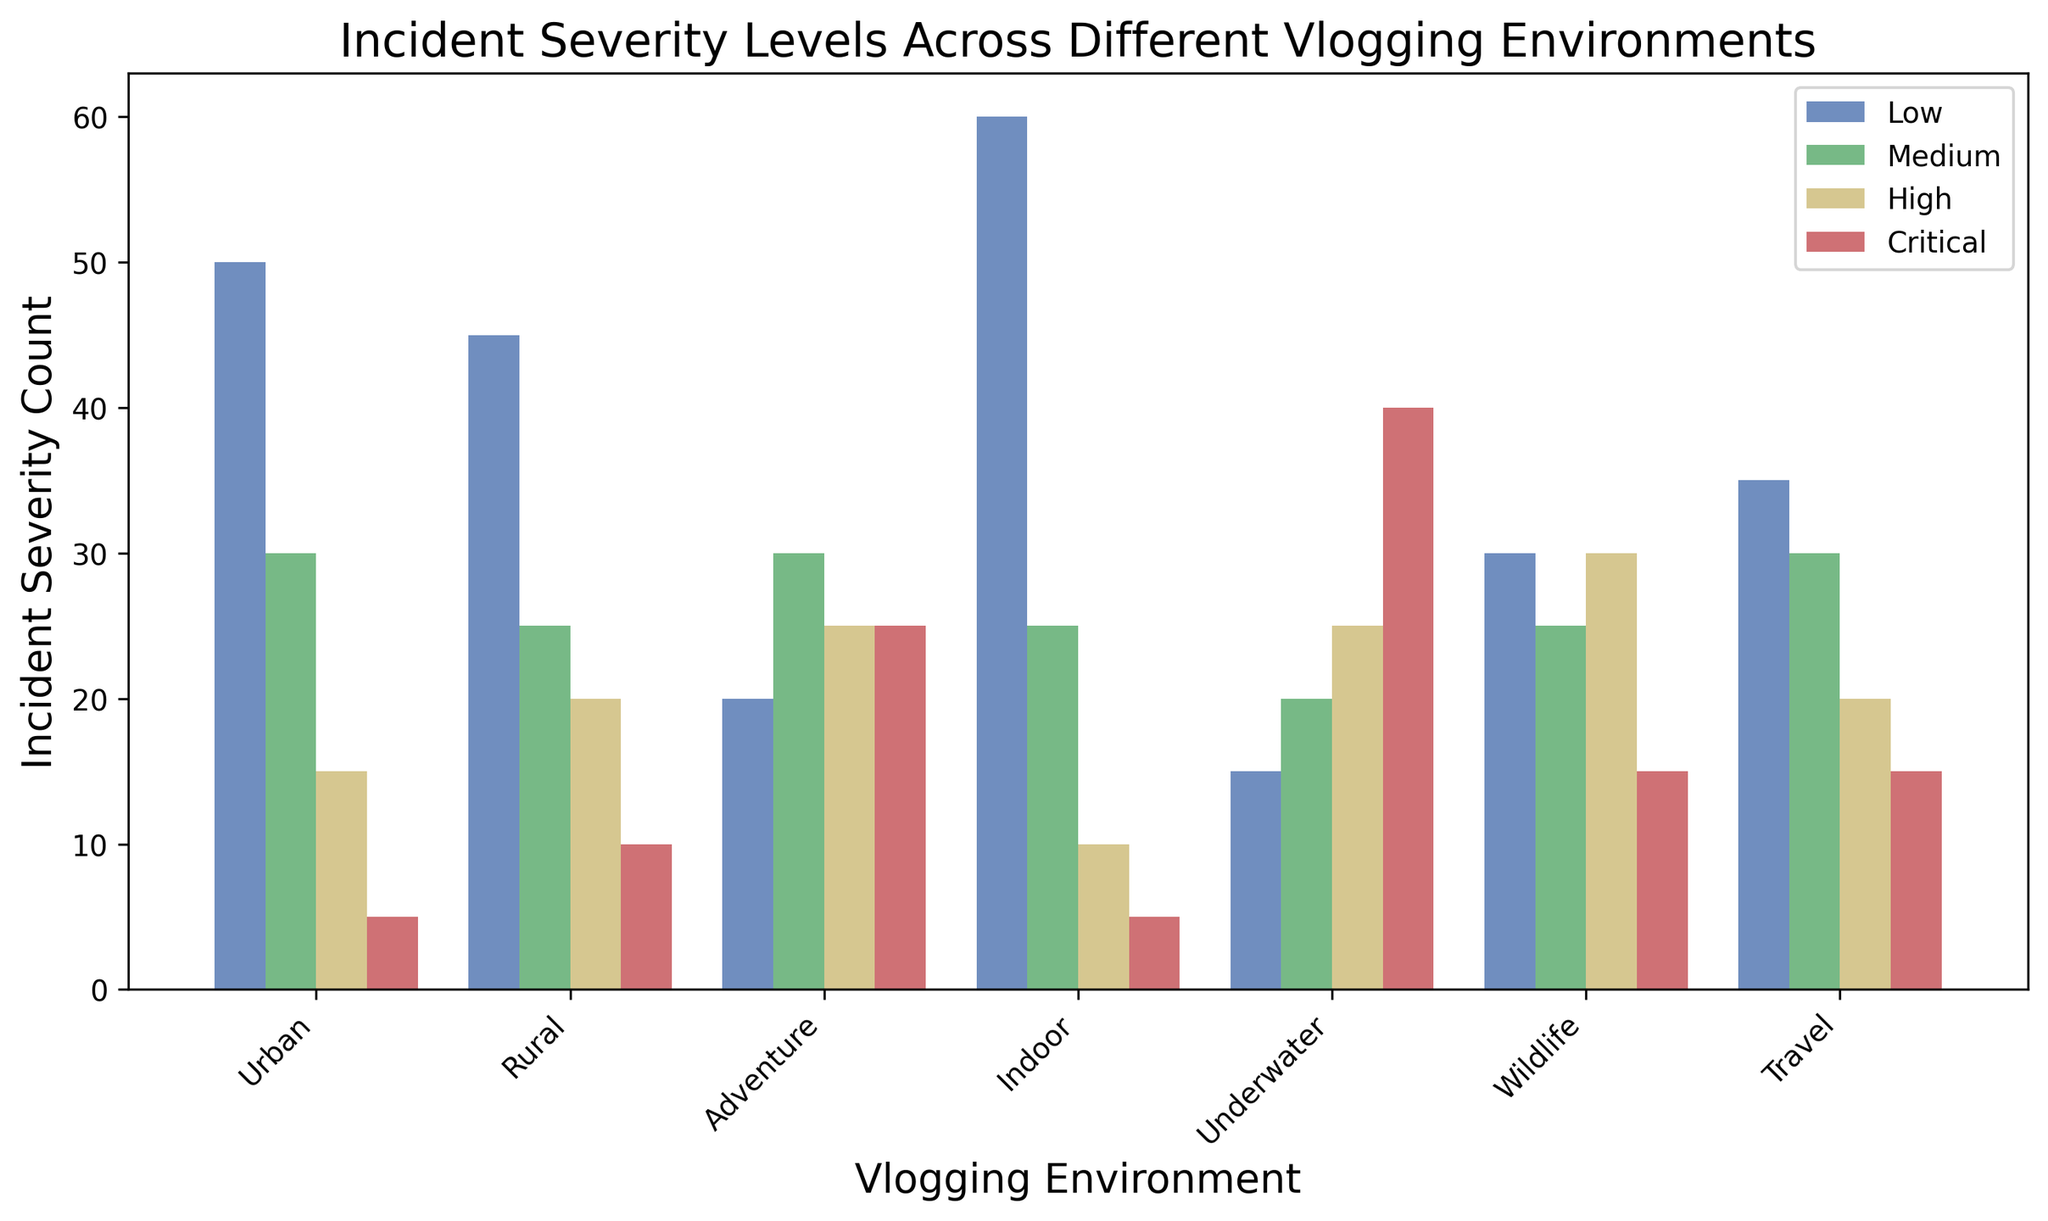What's the environment with the highest critical incident count? First, locate the critical incidents in red. Then visually confirm which environment has the tallest red bar. The tallest bar is in 'Underwater'.
Answer: Underwater Which environment has a higher medium incident count, Urban or Rural? Check the green bars for both Urban and Rural environments. Urban has 30 medium incidents while Rural has 25.
Answer: Urban What is the total incident count for the Urban environment? Sum the counts for Low, Medium, High, and Critical incidents in Urban (50 + 30 + 15 + 5). This gives 100.
Answer: 100 For the Adventure environment, are high or critical incidents more frequent? Compare the heights of the yellow (High) and red (Critical) bars for Adventure. High incidents are 25 and Critical incidents are 25. Both are equal.
Answer: Equal What is the difference in critical incidents between Underwater and Wildlife environments? Look at the red bars for Underwater (40) and Wildlife (15) and calculate the difference (40 - 15).
Answer: 25 Which environment has the smallest number of low incidents? Identify the shortest blue bar across all environments. This bar represents Underwater with 15 low incidents.
Answer: Underwater How many more high incidents are there in Wildlife compared to Indoor? Compare the yellow bars for Wildlife (30) and Indoor (10) and find the difference (30 - 10).
Answer: 20 What is the cumulative count of medium incidents in Rural and Travel environments? Add the green bars for Rural (25) and Travel (30) for the total (25 + 30).
Answer: 55 What environment has the second highest count for low incidents? List the low incident counts and sort them: Indoor (60), Urban (50), Rural (45), Travel (35), Wildlife (30), Adventure (20), Underwater (15). The second highest is Urban with 50 incidents.
Answer: Urban Is there any environment where the count of high incidents is equal to the count of low incidents? Compare each environment's high and low incident bars to see if they are equal. No environment has equal counts of high and low incidents.
Answer: No 